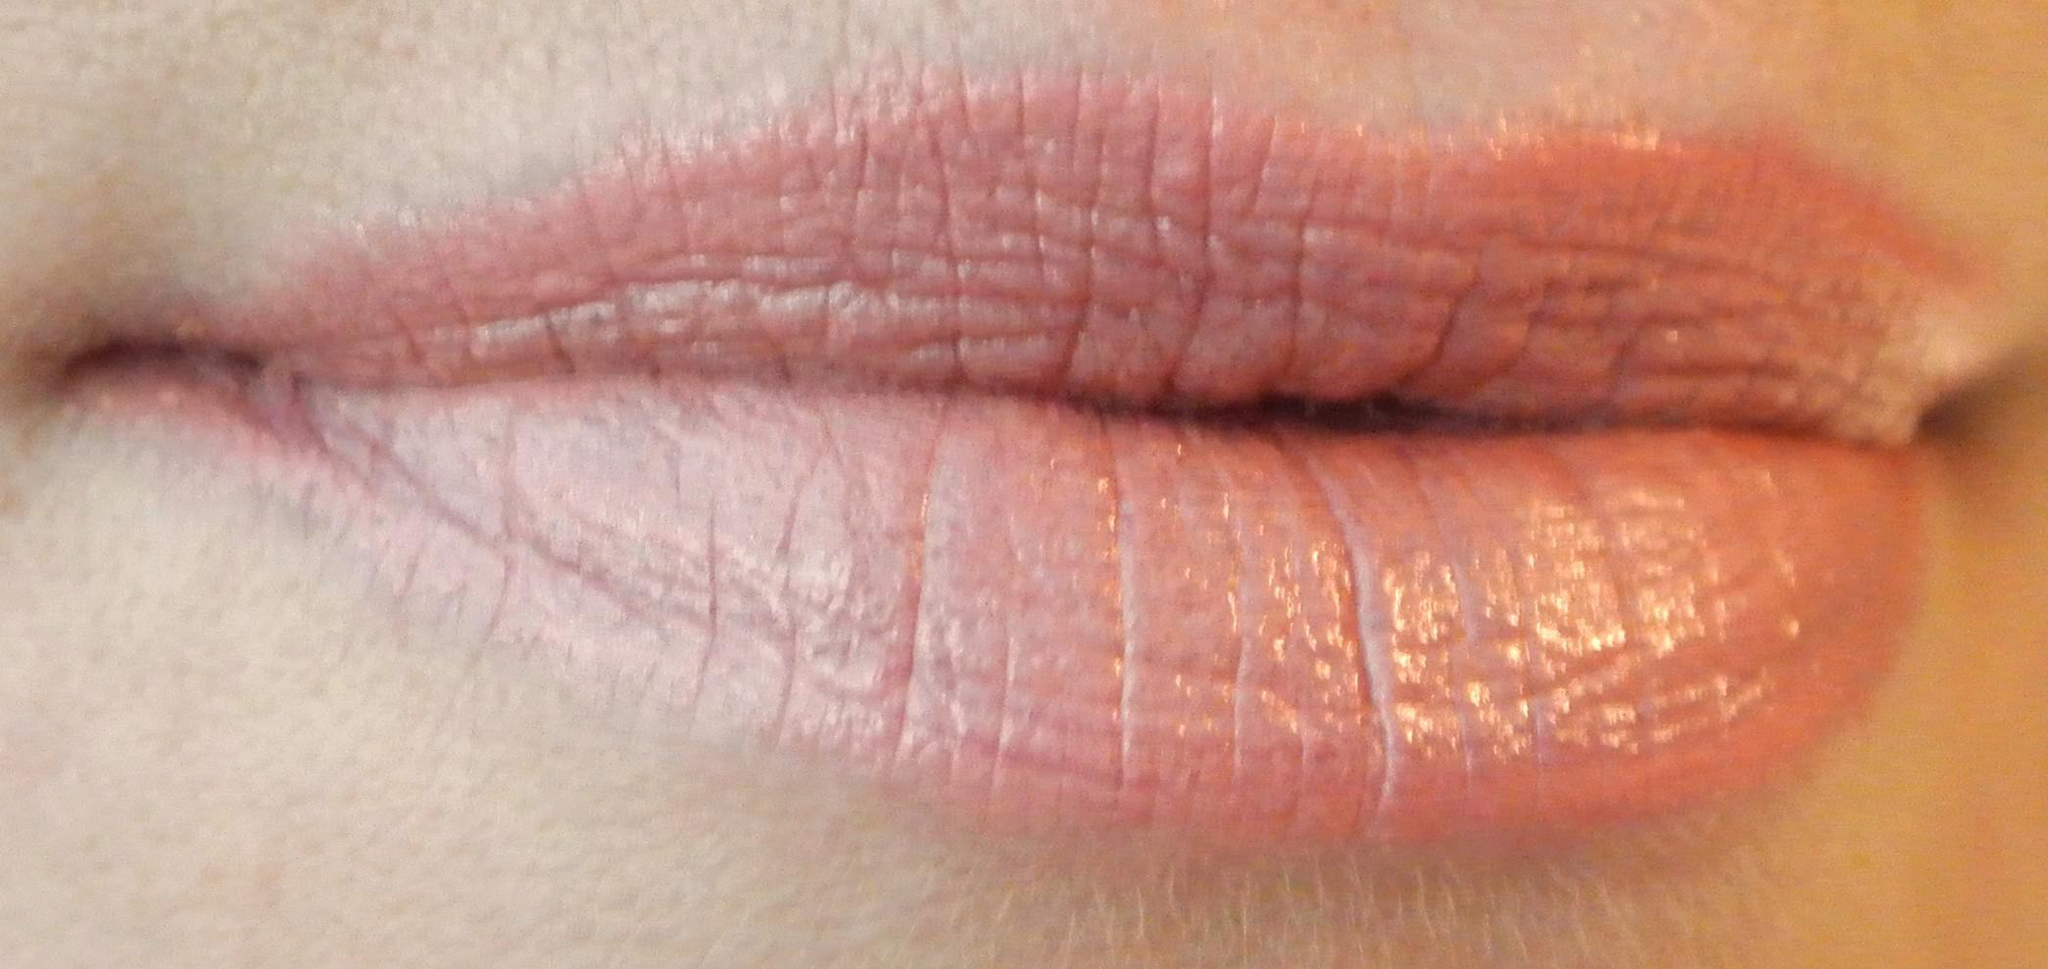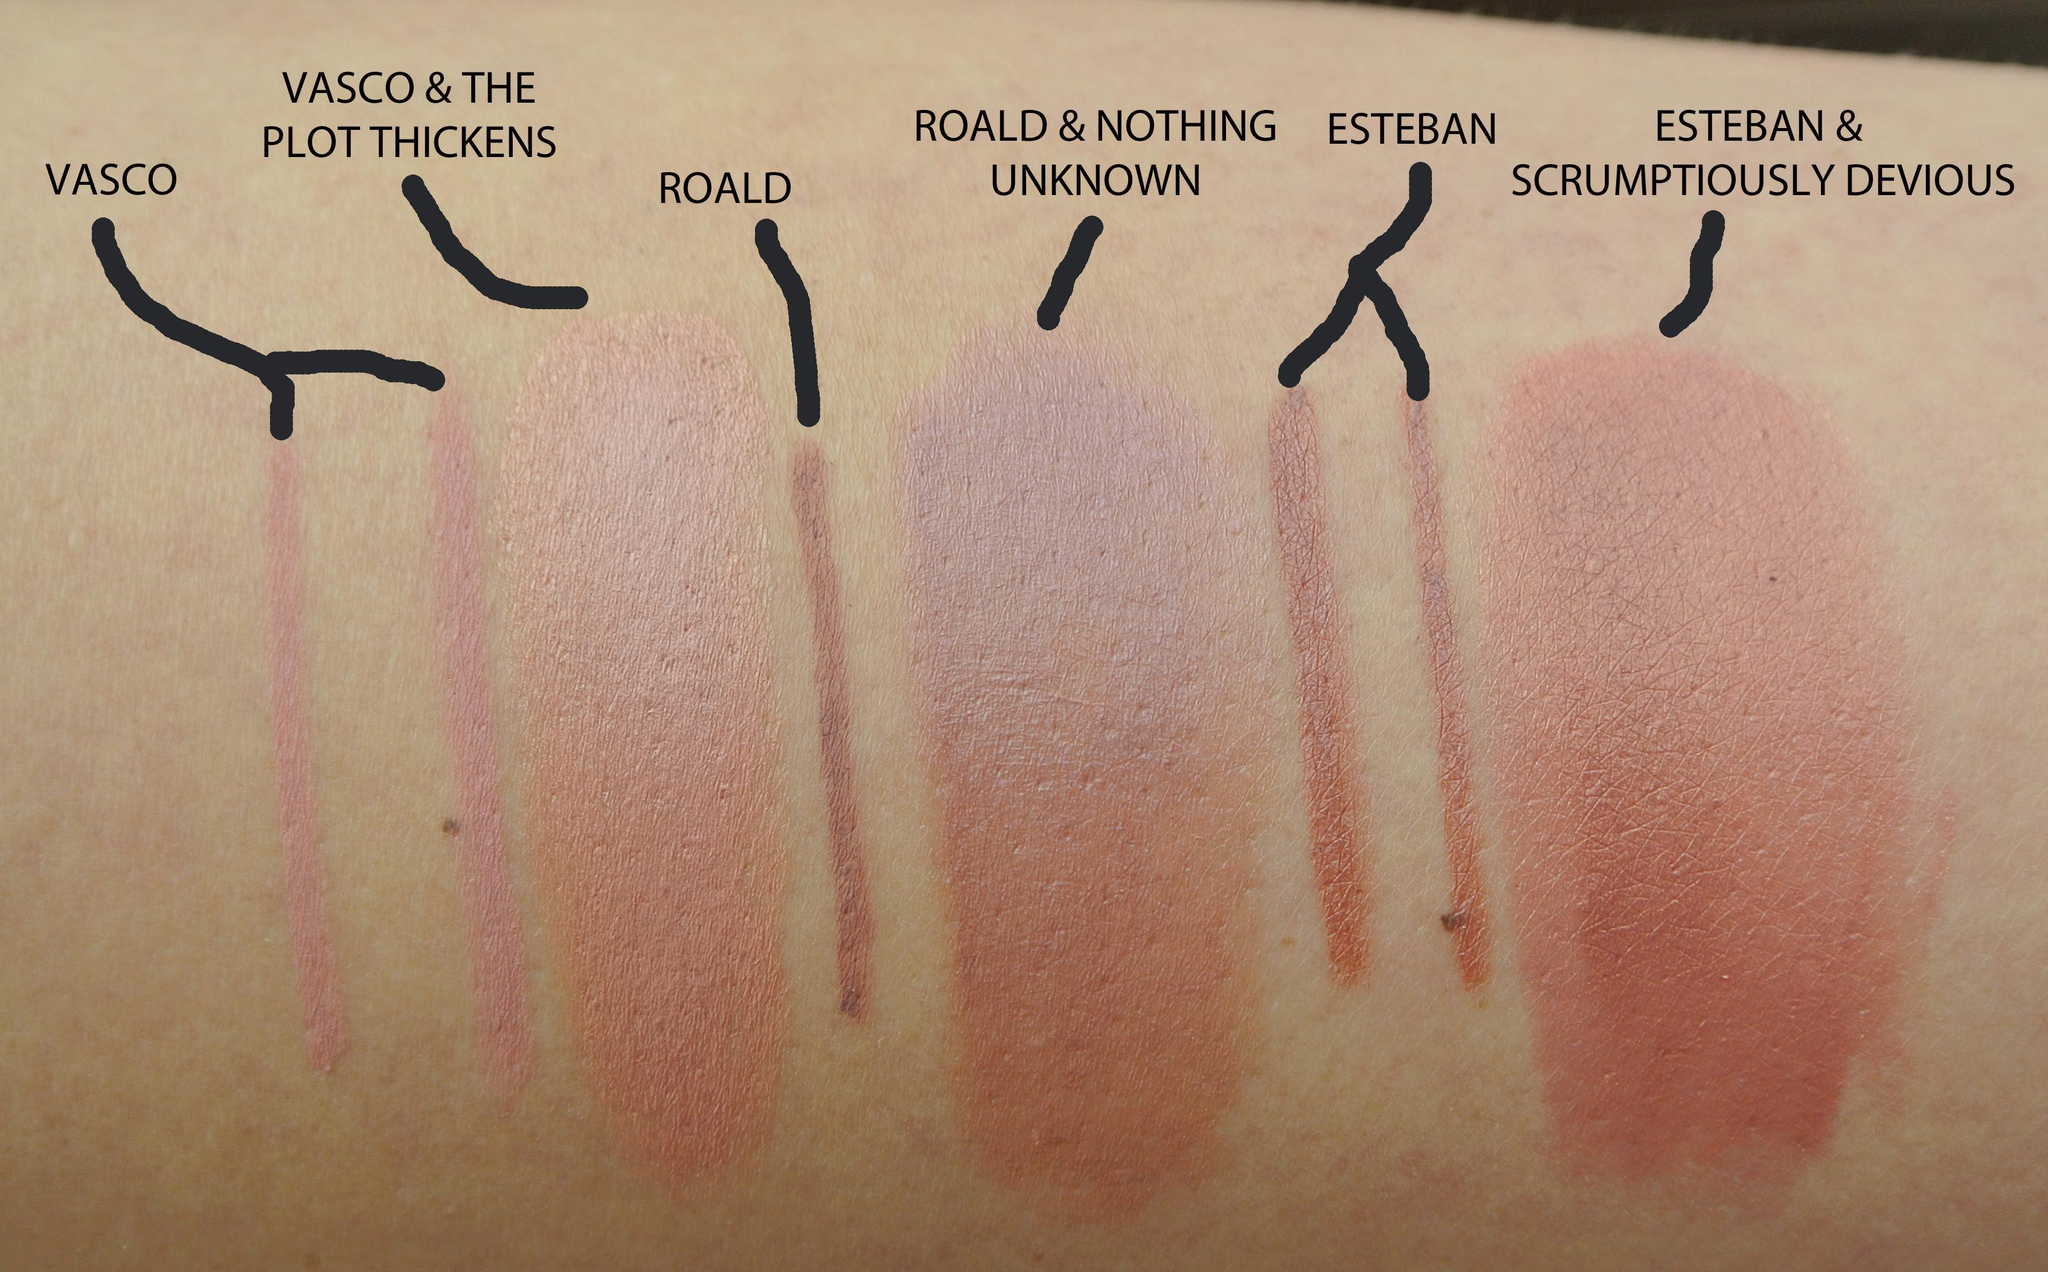The first image is the image on the left, the second image is the image on the right. Given the left and right images, does the statement "One image shows a lipstick shade displayed on lips and the other shows a variety of shades displayed on an arm." hold true? Answer yes or no. Yes. The first image is the image on the left, the second image is the image on the right. Examine the images to the left and right. Is the description "One image features pink tinted lips with no teeth showing, and the other image shows multiple lipstick marks on skin." accurate? Answer yes or no. Yes. 